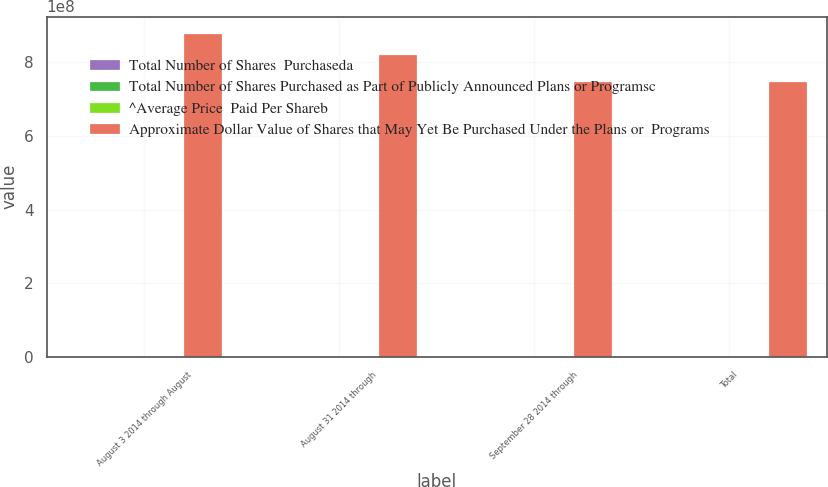<chart> <loc_0><loc_0><loc_500><loc_500><stacked_bar_chart><ecel><fcel>August 3 2014 through August<fcel>August 31 2014 through<fcel>September 28 2014 through<fcel>Total<nl><fcel>Total Number of Shares  Purchaseda<fcel>1.08323e+06<fcel>1.14584e+06<fcel>1.61738e+06<fcel>3.84646e+06<nl><fcel>Total Number of Shares Purchased as Part of Publicly Announced Plans or Programsc<fcel>50.72<fcel>49.91<fcel>46.52<fcel>48.71<nl><fcel>^Average Price  Paid Per Shareb<fcel>1.0642e+06<fcel>1.1412e+06<fcel>1.6124e+06<fcel>3.8178e+06<nl><fcel>Approximate Dollar Value of Shares that May Yet Be Purchased Under the Plans or  Programs<fcel>8.80174e+08<fcel>8.23218e+08<fcel>7.48215e+08<fcel>7.48215e+08<nl></chart> 